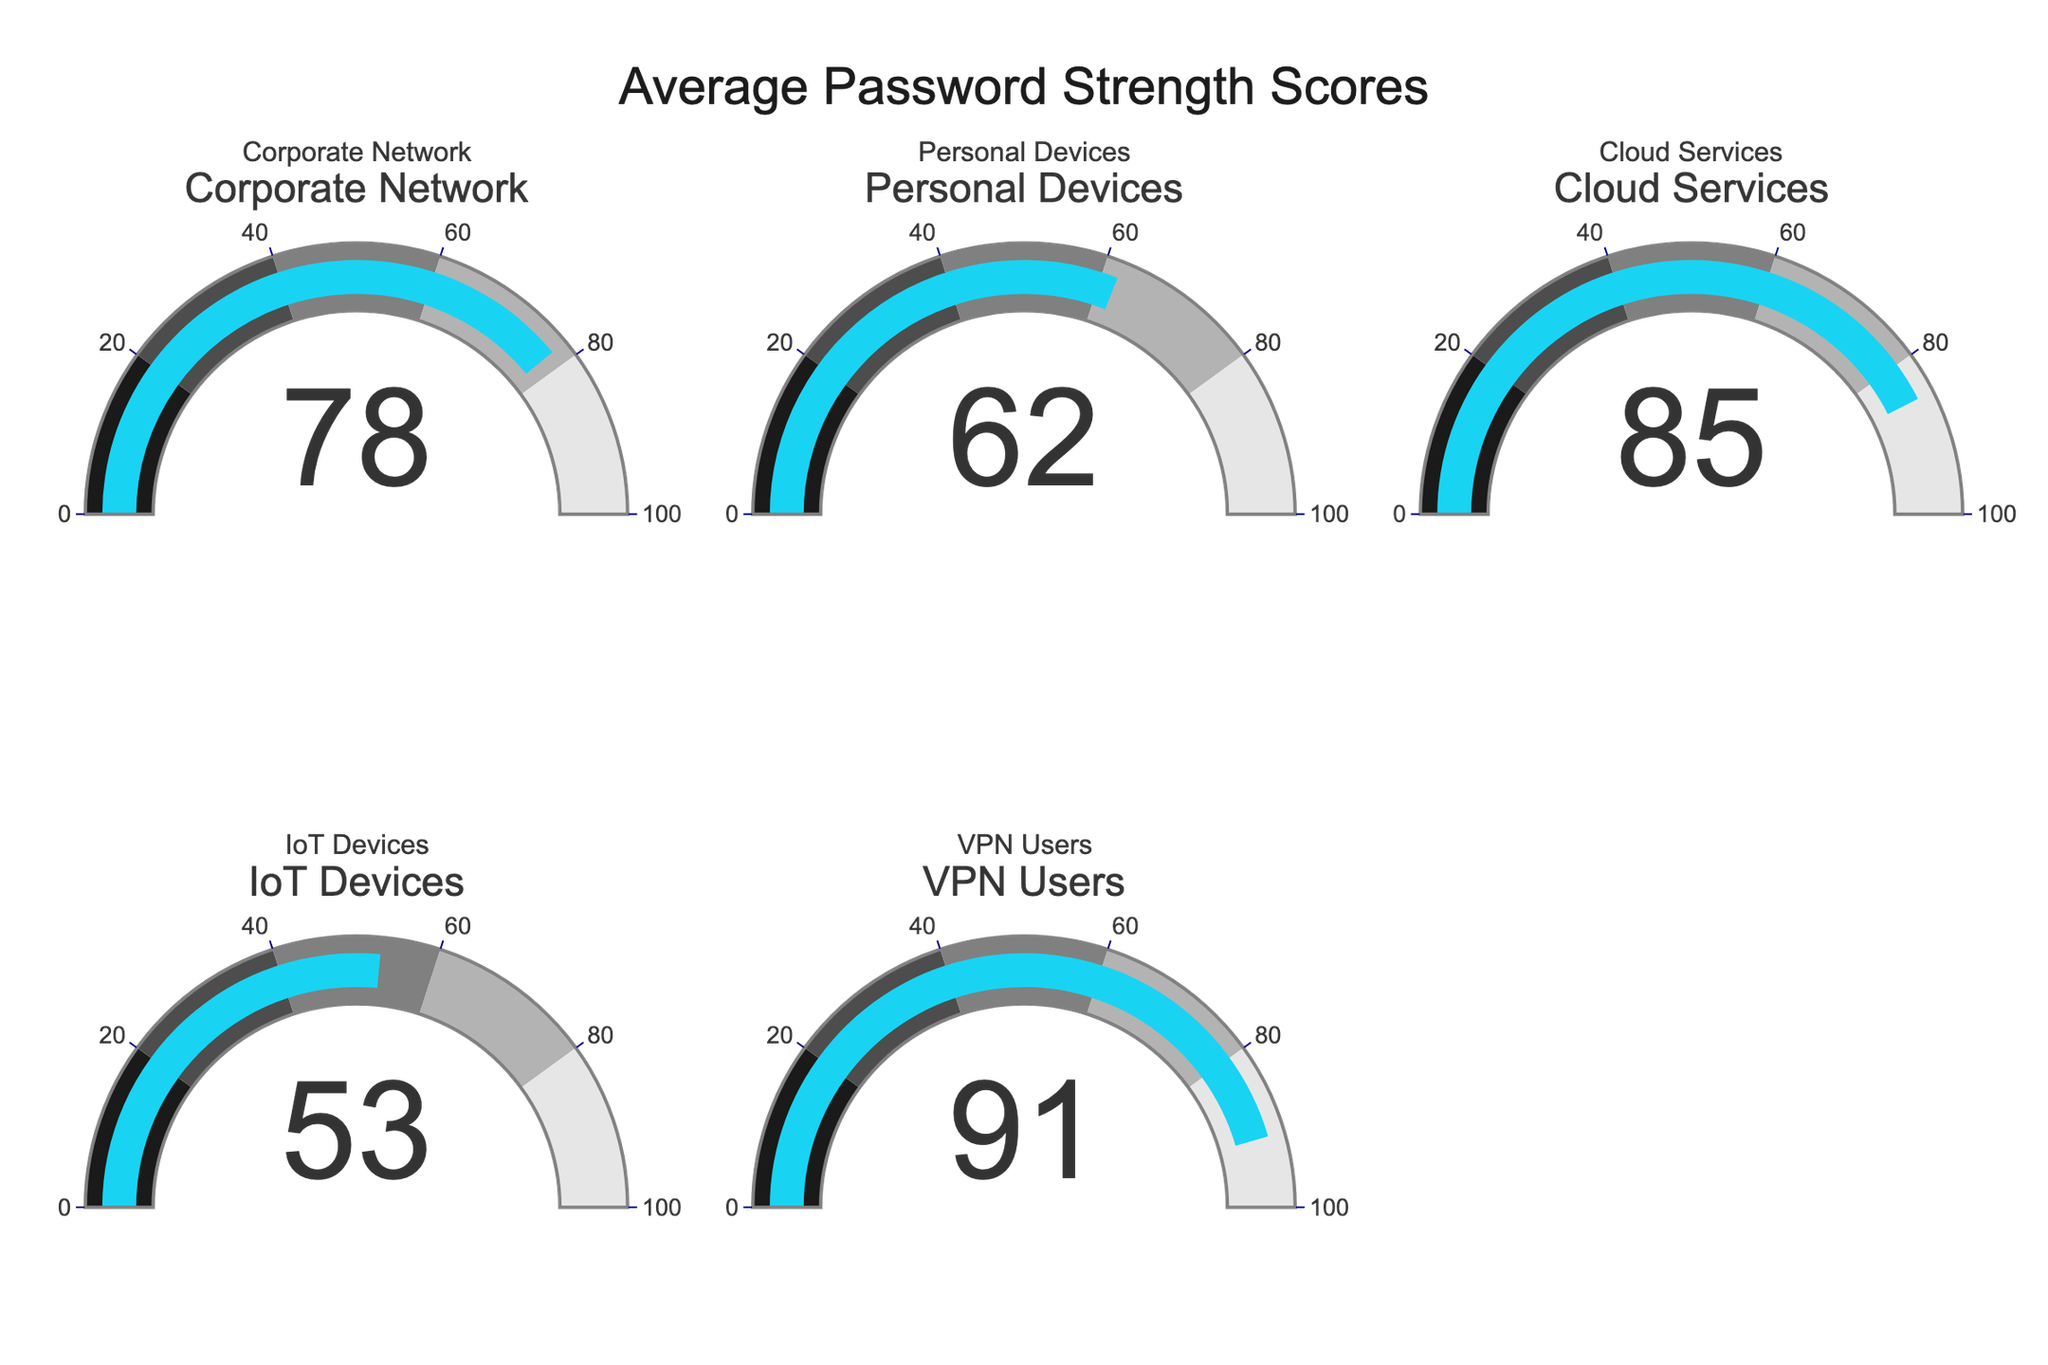What is the average password strength score for Corporate Network? The gauge labeled "Corporate Network" shows a score of 78.
Answer: 78 Which category has the highest password strength score? By examining all gauges, "VPN Users" has the highest value at 91.
Answer: VPN Users Which category has the lowest password strength score? Among the gauges, "IoT Devices" shows the lowest score of 53.
Answer: IoT Devices What is the difference in password strength scores between Cloud Services and Personal Devices? The gauge for Cloud Services shows 85, and Personal Devices shows 62. Subtract the two: 85 - 62 = 23.
Answer: 23 What is the median password strength score across all categories? The scores are 78, 62, 85, 53, 91. When sorted: 53, 62, 78, 85, 91. The middle value is 78.
Answer: 78 What is the range of the password strength scores presented in the gauges? The highest score is 91 (VPN Users), and the lowest is 53 (IoT Devices). The range is 91 - 53 = 38.
Answer: 38 How many categories have a password strength score above 80? The gauges for Cloud Services (85) and VPN Users (91) are above 80. Therefore, there are 2 such categories.
Answer: 2 Is the password strength score for Personal Devices above the average password strength score? The average score can be calculated as (78+62+85+53+91)/5 = 73.8. The score for Personal Devices is 62, which is below 73.8.
Answer: No Are more than half of the password strength scores above 70? The scores above 70 are 78 (Corporate Network), 85 (Cloud Services), and 91 (VPN Users). Thus, 3 out of 5 scores are above 70, which is more than half.
Answer: Yes Which category falls into the second highest color range in the gauge chart? The second highest color range is between 80 and 100. VPN Users (91) and Cloud Services (85) fall within this range.
Answer: VPN Users and Cloud Services 